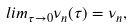Convert formula to latex. <formula><loc_0><loc_0><loc_500><loc_500>l i m _ { \tau \rightarrow 0 } \nu _ { n } ( \tau ) = \nu _ { n } ,</formula> 